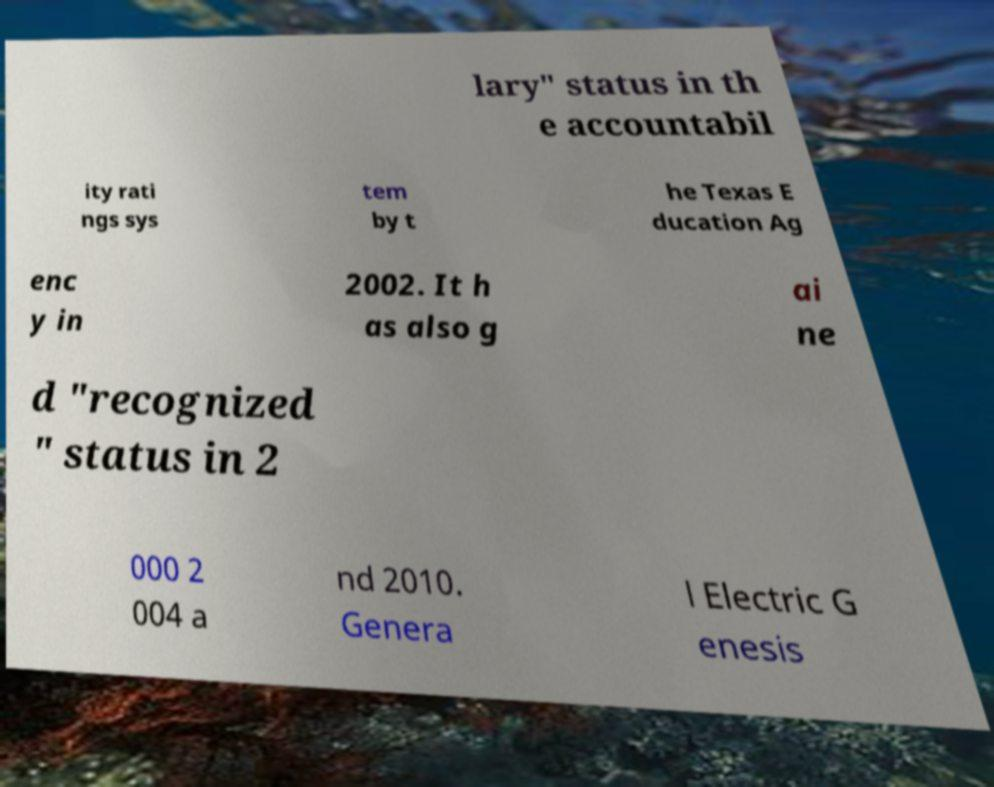Please identify and transcribe the text found in this image. lary" status in th e accountabil ity rati ngs sys tem by t he Texas E ducation Ag enc y in 2002. It h as also g ai ne d "recognized " status in 2 000 2 004 a nd 2010. Genera l Electric G enesis 